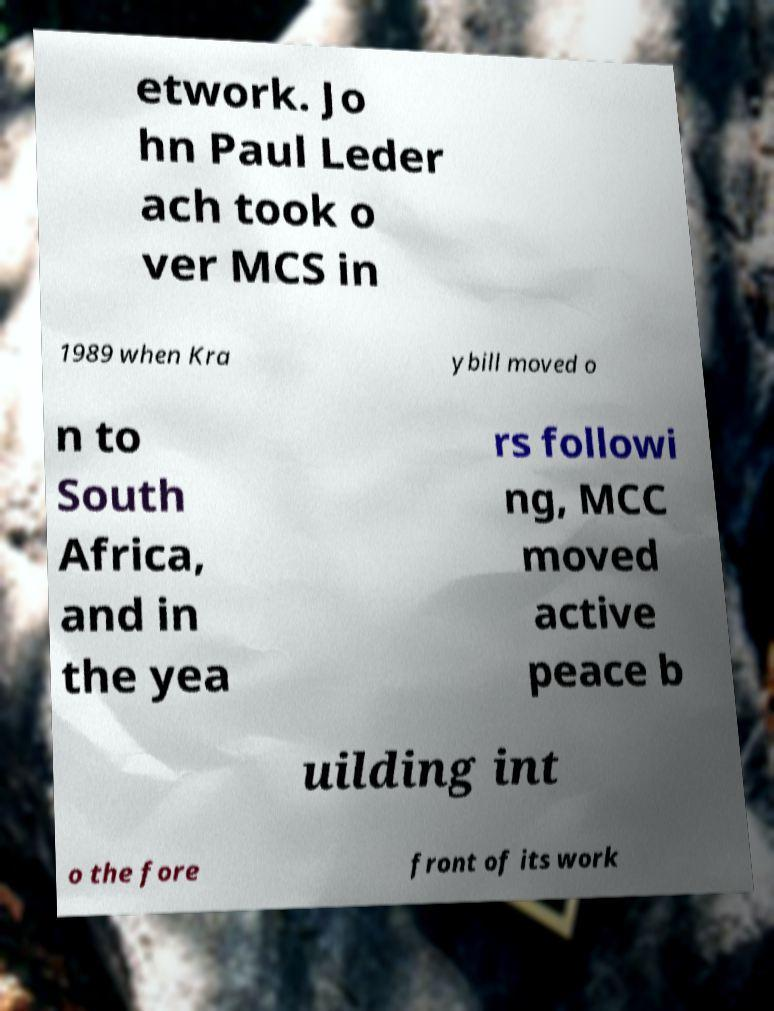Can you accurately transcribe the text from the provided image for me? etwork. Jo hn Paul Leder ach took o ver MCS in 1989 when Kra ybill moved o n to South Africa, and in the yea rs followi ng, MCC moved active peace b uilding int o the fore front of its work 